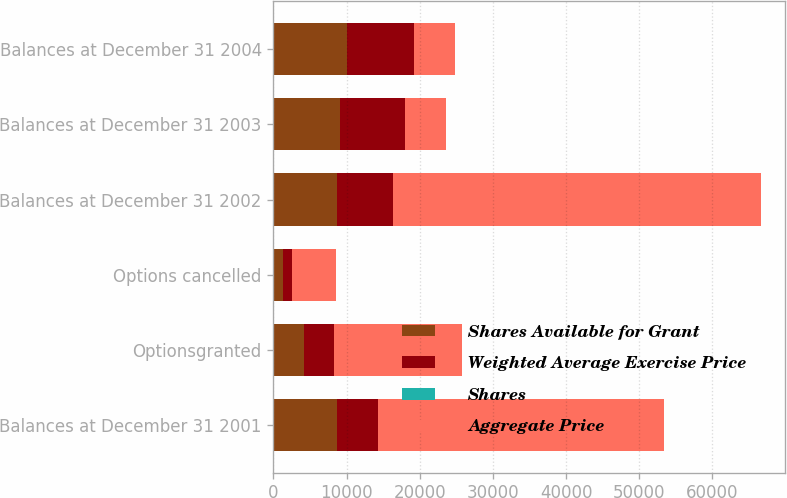Convert chart to OTSL. <chart><loc_0><loc_0><loc_500><loc_500><stacked_bar_chart><ecel><fcel>Balances at December 31 2001<fcel>Optionsgranted<fcel>Options cancelled<fcel>Balances at December 31 2002<fcel>Balances at December 31 2003<fcel>Balances at December 31 2004<nl><fcel>Shares Available for Grant<fcel>8743<fcel>4150<fcel>1299<fcel>8723<fcel>9152<fcel>10112<nl><fcel>Weighted Average Exercise Price<fcel>5489<fcel>4150<fcel>1299<fcel>7670<fcel>8767<fcel>9050<nl><fcel>Shares<fcel>7.14<fcel>4.22<fcel>4.54<fcel>6.54<fcel>7.03<fcel>10.35<nl><fcel>Aggregate Price<fcel>39193<fcel>17513<fcel>5902<fcel>50182<fcel>5695.5<fcel>5695.5<nl></chart> 